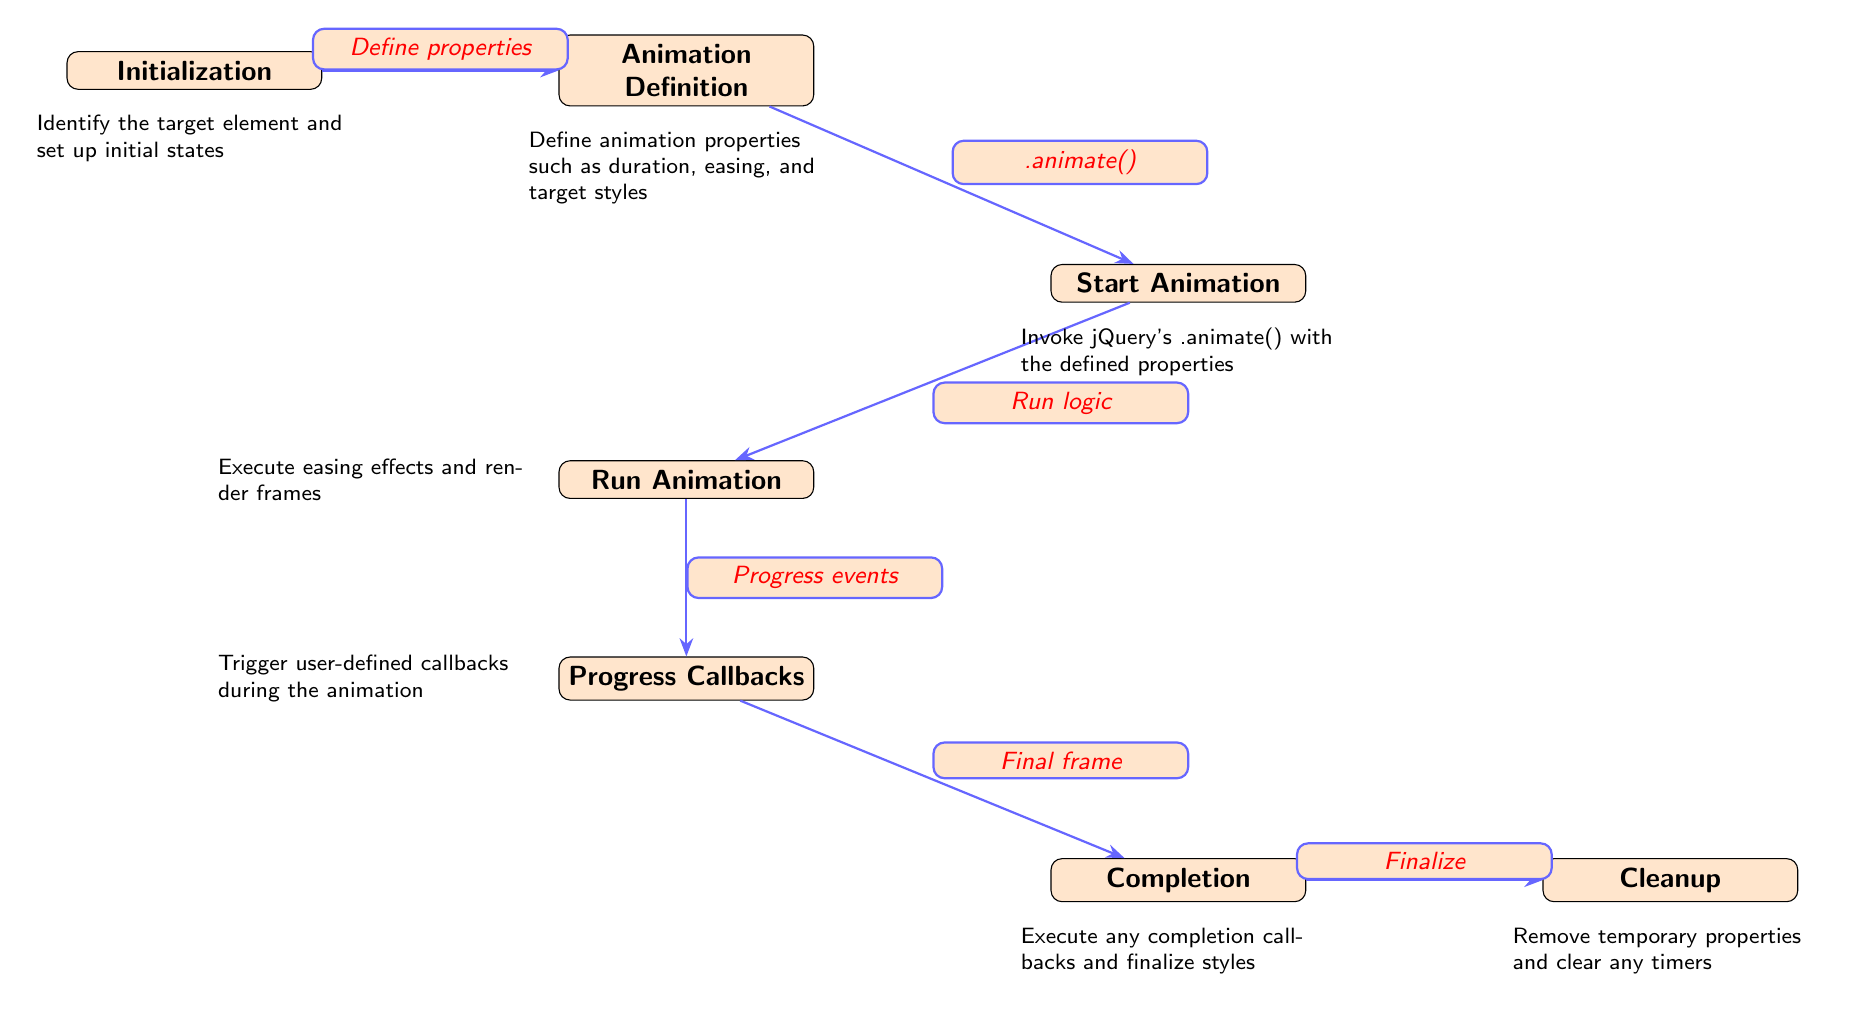What is the first node in the diagram? The first node in the diagram is labeled "Initialization," which is the starting point of the jQuery animation lifecycle.
Answer: Initialization How many nodes are present in the diagram? Counting all nodes, there are a total of seven nodes representing different stages in the animation lifecycle.
Answer: Seven What action defines the transition from "Initialization" to "Animation Definition"? The action that defines the transition is "Define properties," which indicates the step of identifying animation attributes.
Answer: Define properties What is the final stage of the jQuery animation lifecycle? The final stage, shown as the last node in the diagram, is labeled "Cleanup," which indicates the process of tidying up after the animation completes.
Answer: Cleanup Which node involves invoking jQuery's .animate()? The node labeled "Start Animation" is the one where jQuery's .animate() is invoked with the previously defined properties.
Answer: Start Animation What type of callbacks are triggered during the animation? The node "Progress Callbacks" indicates that user-defined callbacks are triggered throughout the animation process, specifically during its progress.
Answer: Progress Callbacks Which two nodes are involved in the completion of the animation? The nodes "Completion" and "Cleanup" represent the finalization process, where callbacks are executed and temporary properties are removed.
Answer: Completion and Cleanup What is executed in the "Run Animation" stage? The "Run Animation" stage involves executing easing effects and rendering frames to create the visual transition of the animation.
Answer: Easing effects and rendering frames What is the relationship between "Progress Callbacks" and "Completion"? The relationship indicates that after progress events occur, the animation proceeds to its final frame represented by "Completion." Thus, "Progress Callbacks" leads to "Completion."
Answer: Progress events lead to Completion 